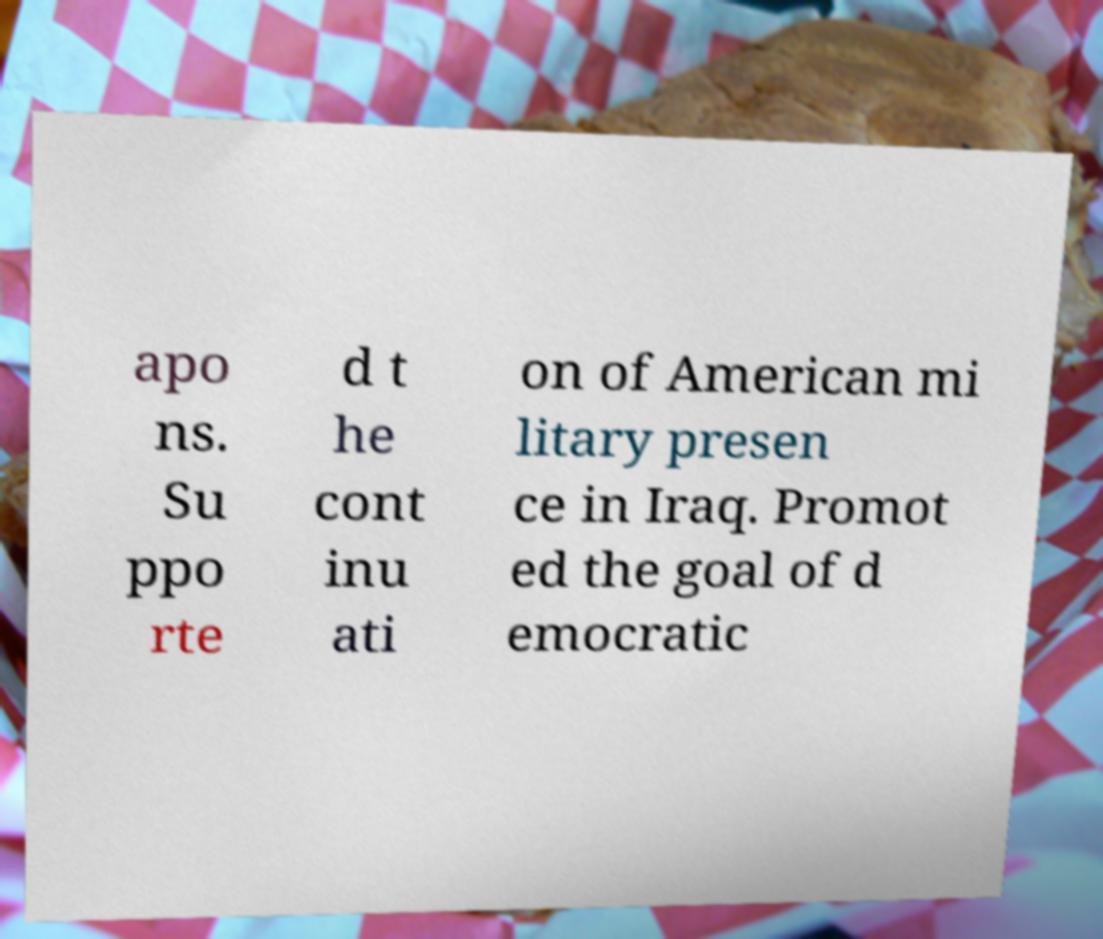I need the written content from this picture converted into text. Can you do that? apo ns. Su ppo rte d t he cont inu ati on of American mi litary presen ce in Iraq. Promot ed the goal of d emocratic 